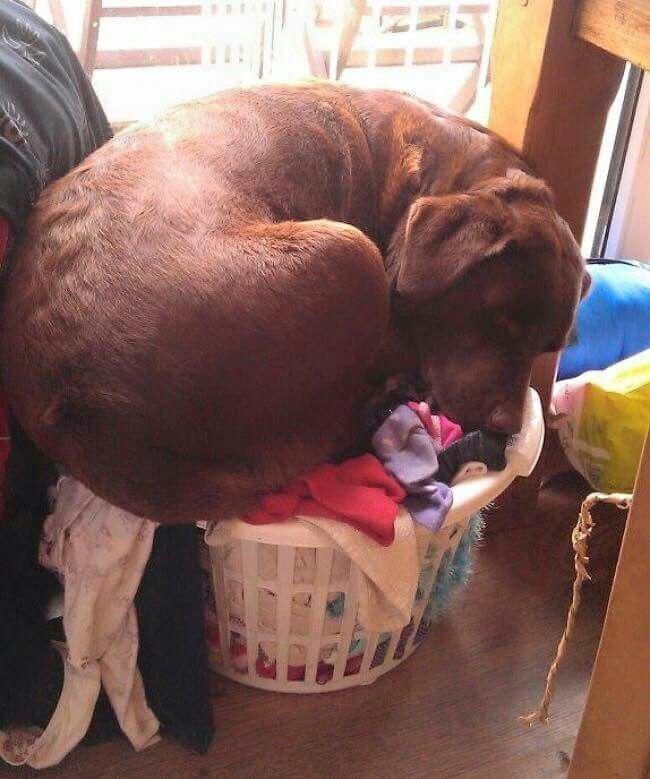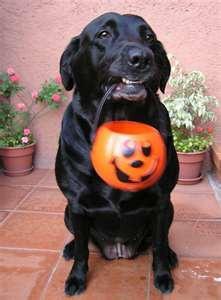The first image is the image on the left, the second image is the image on the right. Examine the images to the left and right. Is the description "a human is posing with a brown lab" accurate? Answer yes or no. No. The first image is the image on the left, the second image is the image on the right. For the images displayed, is the sentence "There is one human and one dog in the right image." factually correct? Answer yes or no. No. 